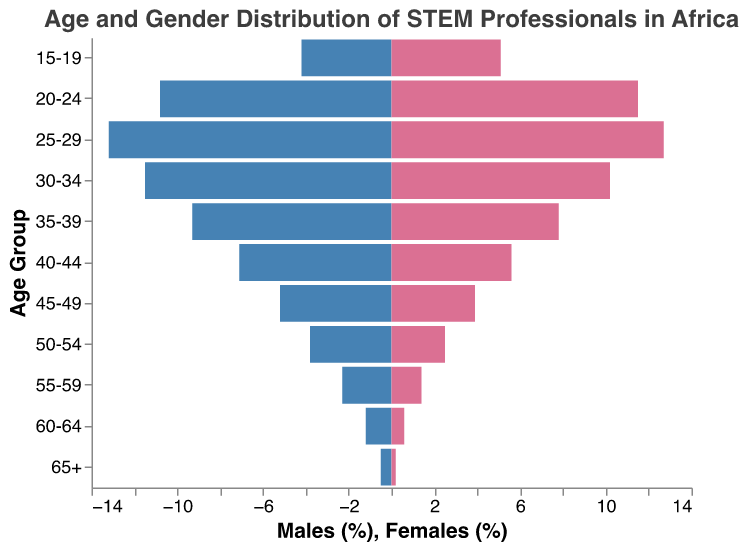What is the title of the population pyramid? The title of the plot can be read directly from the top of the figure.
Answer: Age and Gender Distribution of STEM Professionals in Africa Which age group has the highest percentage of males? To find the age group with the highest percentage of males, look for the largest blue bar on the left side of the pyramid.
Answer: 25-29 What is the percentage difference between males and females in the 20-24 age group? Subtract the percentage of females from the percentage of males in the 20-24 age group.
Answer: -0.7% Which age group has a higher percentage of females compared to males? Check each age group's bars and identify where the red bar (females) is longer than the blue bar (males).
Answer: 15-19 How does the representation of women in the 25-29 age group compare to that in the 65+ age group? Compare the length of the red bars for the 25-29 and 65+ age groups. The length of the bar represents the percentage value.
Answer: Higher in 25-29 What trend do you observe in the percentage of females as the age groups increase from 15-19 to 65+? Observe the length of red bars representing the percentage of females across increasing age groups to identify any trends.
Answer: Decreasing Calculate the total percentage of STEM professionals in the 50-54 age group. Add the percentages of males and females in the 50-54 age group. 3.8 (males) + 2.5 (females) = 6.3
Answer: 6.3 In which age group do we see the greatest gender disparity? Identify the age group with the largest difference in the bar lengths between males and females.
Answer: 45-49 What is the combined percentage of males and females in the 30-34 age group? Add the percentages of males and females in the 30-34 age group. 11.5 (males) + 10.2 (females) = 21.7
Answer: 21.7 